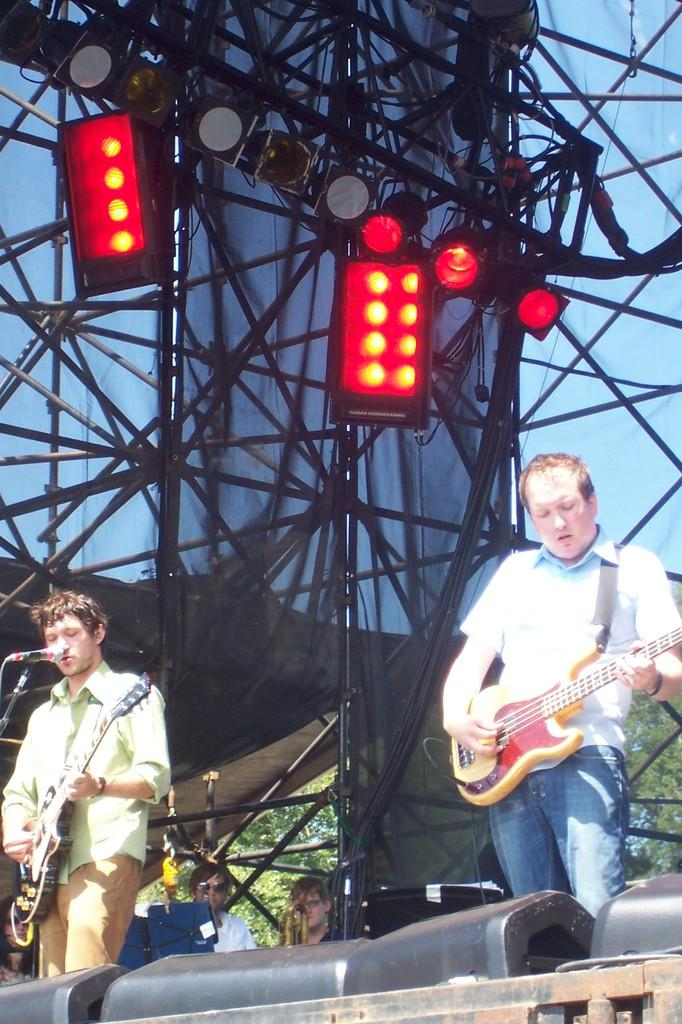How many people are in the image? There are two men in the image. Where are the men located in the image? The men are standing on a stage. What are the men doing in the image? The men are playing a guitar. What color are the lights in the image? The lights in the image are red. How are the red lights positioned in the image? The red lights are focused on the men from the top. What type of cushion is being used by the rat in the image? There is no rat or cushion present in the image. 